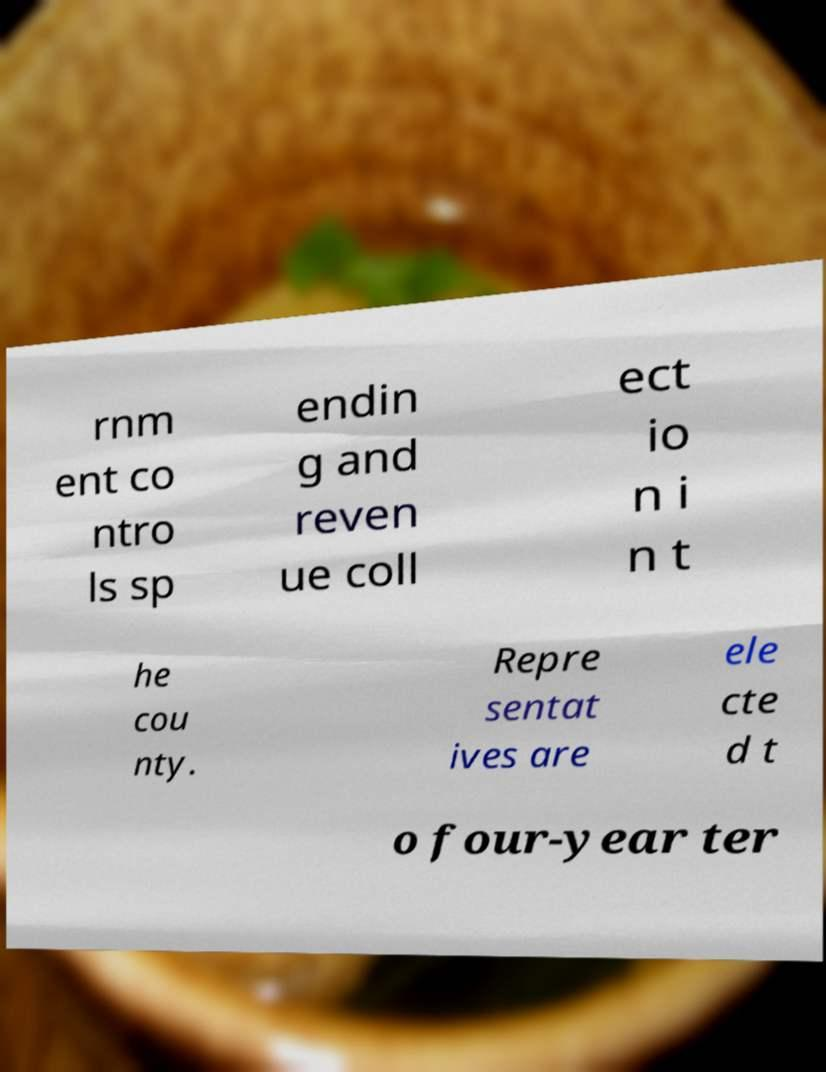For documentation purposes, I need the text within this image transcribed. Could you provide that? rnm ent co ntro ls sp endin g and reven ue coll ect io n i n t he cou nty. Repre sentat ives are ele cte d t o four-year ter 